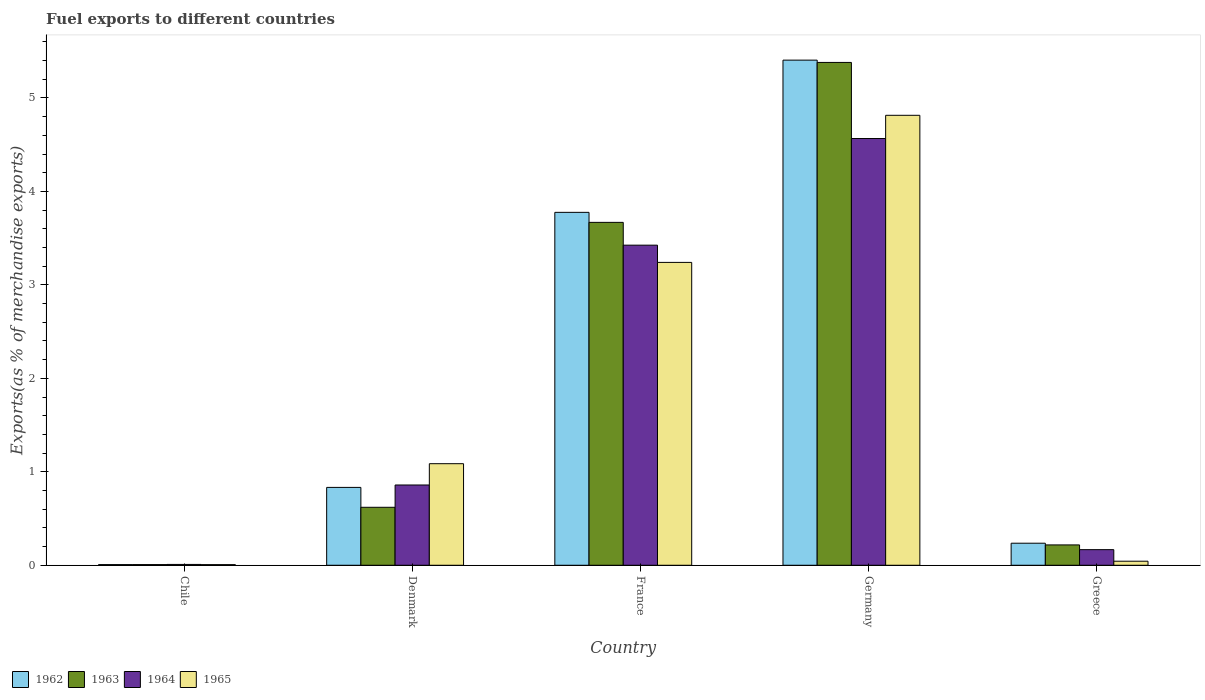Are the number of bars per tick equal to the number of legend labels?
Make the answer very short. Yes. Are the number of bars on each tick of the X-axis equal?
Provide a succinct answer. Yes. How many bars are there on the 3rd tick from the left?
Your answer should be compact. 4. How many bars are there on the 2nd tick from the right?
Your response must be concise. 4. What is the label of the 2nd group of bars from the left?
Your answer should be very brief. Denmark. In how many cases, is the number of bars for a given country not equal to the number of legend labels?
Your answer should be compact. 0. What is the percentage of exports to different countries in 1963 in Greece?
Provide a short and direct response. 0.22. Across all countries, what is the maximum percentage of exports to different countries in 1965?
Your response must be concise. 4.81. Across all countries, what is the minimum percentage of exports to different countries in 1964?
Make the answer very short. 0.01. In which country was the percentage of exports to different countries in 1963 maximum?
Ensure brevity in your answer.  Germany. In which country was the percentage of exports to different countries in 1963 minimum?
Keep it short and to the point. Chile. What is the total percentage of exports to different countries in 1965 in the graph?
Your response must be concise. 9.19. What is the difference between the percentage of exports to different countries in 1964 in Chile and that in Germany?
Keep it short and to the point. -4.56. What is the difference between the percentage of exports to different countries in 1964 in Chile and the percentage of exports to different countries in 1962 in Germany?
Offer a very short reply. -5.4. What is the average percentage of exports to different countries in 1963 per country?
Keep it short and to the point. 1.98. What is the difference between the percentage of exports to different countries of/in 1965 and percentage of exports to different countries of/in 1964 in Greece?
Provide a short and direct response. -0.12. In how many countries, is the percentage of exports to different countries in 1963 greater than 4.2 %?
Your answer should be very brief. 1. What is the ratio of the percentage of exports to different countries in 1963 in Chile to that in Denmark?
Offer a very short reply. 0.01. What is the difference between the highest and the second highest percentage of exports to different countries in 1964?
Offer a terse response. -2.57. What is the difference between the highest and the lowest percentage of exports to different countries in 1965?
Your response must be concise. 4.81. Is it the case that in every country, the sum of the percentage of exports to different countries in 1963 and percentage of exports to different countries in 1965 is greater than the sum of percentage of exports to different countries in 1962 and percentage of exports to different countries in 1964?
Offer a very short reply. No. What does the 1st bar from the left in Germany represents?
Provide a succinct answer. 1962. What does the 4th bar from the right in Chile represents?
Your response must be concise. 1962. How many bars are there?
Offer a very short reply. 20. What is the difference between two consecutive major ticks on the Y-axis?
Ensure brevity in your answer.  1. Does the graph contain grids?
Ensure brevity in your answer.  No. Where does the legend appear in the graph?
Keep it short and to the point. Bottom left. How are the legend labels stacked?
Give a very brief answer. Horizontal. What is the title of the graph?
Provide a short and direct response. Fuel exports to different countries. What is the label or title of the Y-axis?
Provide a succinct answer. Exports(as % of merchandise exports). What is the Exports(as % of merchandise exports) of 1962 in Chile?
Provide a short and direct response. 0.01. What is the Exports(as % of merchandise exports) of 1963 in Chile?
Your answer should be very brief. 0.01. What is the Exports(as % of merchandise exports) of 1964 in Chile?
Keep it short and to the point. 0.01. What is the Exports(as % of merchandise exports) of 1965 in Chile?
Your response must be concise. 0.01. What is the Exports(as % of merchandise exports) of 1962 in Denmark?
Make the answer very short. 0.83. What is the Exports(as % of merchandise exports) in 1963 in Denmark?
Provide a short and direct response. 0.62. What is the Exports(as % of merchandise exports) in 1964 in Denmark?
Your answer should be compact. 0.86. What is the Exports(as % of merchandise exports) of 1965 in Denmark?
Ensure brevity in your answer.  1.09. What is the Exports(as % of merchandise exports) in 1962 in France?
Give a very brief answer. 3.78. What is the Exports(as % of merchandise exports) of 1963 in France?
Give a very brief answer. 3.67. What is the Exports(as % of merchandise exports) in 1964 in France?
Your answer should be compact. 3.43. What is the Exports(as % of merchandise exports) of 1965 in France?
Provide a short and direct response. 3.24. What is the Exports(as % of merchandise exports) in 1962 in Germany?
Give a very brief answer. 5.4. What is the Exports(as % of merchandise exports) of 1963 in Germany?
Provide a succinct answer. 5.38. What is the Exports(as % of merchandise exports) in 1964 in Germany?
Your answer should be compact. 4.57. What is the Exports(as % of merchandise exports) of 1965 in Germany?
Give a very brief answer. 4.81. What is the Exports(as % of merchandise exports) of 1962 in Greece?
Offer a very short reply. 0.24. What is the Exports(as % of merchandise exports) of 1963 in Greece?
Provide a short and direct response. 0.22. What is the Exports(as % of merchandise exports) in 1964 in Greece?
Provide a short and direct response. 0.17. What is the Exports(as % of merchandise exports) in 1965 in Greece?
Your response must be concise. 0.04. Across all countries, what is the maximum Exports(as % of merchandise exports) in 1962?
Offer a very short reply. 5.4. Across all countries, what is the maximum Exports(as % of merchandise exports) in 1963?
Give a very brief answer. 5.38. Across all countries, what is the maximum Exports(as % of merchandise exports) of 1964?
Offer a very short reply. 4.57. Across all countries, what is the maximum Exports(as % of merchandise exports) in 1965?
Provide a short and direct response. 4.81. Across all countries, what is the minimum Exports(as % of merchandise exports) in 1962?
Make the answer very short. 0.01. Across all countries, what is the minimum Exports(as % of merchandise exports) in 1963?
Offer a terse response. 0.01. Across all countries, what is the minimum Exports(as % of merchandise exports) of 1964?
Make the answer very short. 0.01. Across all countries, what is the minimum Exports(as % of merchandise exports) of 1965?
Ensure brevity in your answer.  0.01. What is the total Exports(as % of merchandise exports) in 1962 in the graph?
Provide a short and direct response. 10.26. What is the total Exports(as % of merchandise exports) of 1963 in the graph?
Ensure brevity in your answer.  9.89. What is the total Exports(as % of merchandise exports) in 1964 in the graph?
Keep it short and to the point. 9.03. What is the total Exports(as % of merchandise exports) in 1965 in the graph?
Offer a terse response. 9.19. What is the difference between the Exports(as % of merchandise exports) of 1962 in Chile and that in Denmark?
Offer a terse response. -0.83. What is the difference between the Exports(as % of merchandise exports) of 1963 in Chile and that in Denmark?
Ensure brevity in your answer.  -0.61. What is the difference between the Exports(as % of merchandise exports) of 1964 in Chile and that in Denmark?
Give a very brief answer. -0.85. What is the difference between the Exports(as % of merchandise exports) of 1965 in Chile and that in Denmark?
Offer a terse response. -1.08. What is the difference between the Exports(as % of merchandise exports) of 1962 in Chile and that in France?
Provide a short and direct response. -3.77. What is the difference between the Exports(as % of merchandise exports) of 1963 in Chile and that in France?
Provide a succinct answer. -3.66. What is the difference between the Exports(as % of merchandise exports) of 1964 in Chile and that in France?
Give a very brief answer. -3.42. What is the difference between the Exports(as % of merchandise exports) of 1965 in Chile and that in France?
Give a very brief answer. -3.23. What is the difference between the Exports(as % of merchandise exports) in 1962 in Chile and that in Germany?
Provide a succinct answer. -5.4. What is the difference between the Exports(as % of merchandise exports) of 1963 in Chile and that in Germany?
Ensure brevity in your answer.  -5.37. What is the difference between the Exports(as % of merchandise exports) of 1964 in Chile and that in Germany?
Provide a succinct answer. -4.56. What is the difference between the Exports(as % of merchandise exports) of 1965 in Chile and that in Germany?
Provide a short and direct response. -4.81. What is the difference between the Exports(as % of merchandise exports) in 1962 in Chile and that in Greece?
Keep it short and to the point. -0.23. What is the difference between the Exports(as % of merchandise exports) of 1963 in Chile and that in Greece?
Provide a short and direct response. -0.21. What is the difference between the Exports(as % of merchandise exports) of 1964 in Chile and that in Greece?
Your response must be concise. -0.16. What is the difference between the Exports(as % of merchandise exports) of 1965 in Chile and that in Greece?
Give a very brief answer. -0.04. What is the difference between the Exports(as % of merchandise exports) in 1962 in Denmark and that in France?
Your answer should be very brief. -2.94. What is the difference between the Exports(as % of merchandise exports) in 1963 in Denmark and that in France?
Your response must be concise. -3.05. What is the difference between the Exports(as % of merchandise exports) of 1964 in Denmark and that in France?
Offer a very short reply. -2.57. What is the difference between the Exports(as % of merchandise exports) in 1965 in Denmark and that in France?
Provide a succinct answer. -2.15. What is the difference between the Exports(as % of merchandise exports) in 1962 in Denmark and that in Germany?
Offer a terse response. -4.57. What is the difference between the Exports(as % of merchandise exports) in 1963 in Denmark and that in Germany?
Your answer should be compact. -4.76. What is the difference between the Exports(as % of merchandise exports) of 1964 in Denmark and that in Germany?
Make the answer very short. -3.71. What is the difference between the Exports(as % of merchandise exports) in 1965 in Denmark and that in Germany?
Offer a terse response. -3.73. What is the difference between the Exports(as % of merchandise exports) in 1962 in Denmark and that in Greece?
Your response must be concise. 0.6. What is the difference between the Exports(as % of merchandise exports) of 1963 in Denmark and that in Greece?
Provide a succinct answer. 0.4. What is the difference between the Exports(as % of merchandise exports) in 1964 in Denmark and that in Greece?
Offer a very short reply. 0.69. What is the difference between the Exports(as % of merchandise exports) in 1965 in Denmark and that in Greece?
Make the answer very short. 1.04. What is the difference between the Exports(as % of merchandise exports) of 1962 in France and that in Germany?
Offer a terse response. -1.63. What is the difference between the Exports(as % of merchandise exports) of 1963 in France and that in Germany?
Keep it short and to the point. -1.71. What is the difference between the Exports(as % of merchandise exports) of 1964 in France and that in Germany?
Keep it short and to the point. -1.14. What is the difference between the Exports(as % of merchandise exports) in 1965 in France and that in Germany?
Your answer should be very brief. -1.57. What is the difference between the Exports(as % of merchandise exports) in 1962 in France and that in Greece?
Keep it short and to the point. 3.54. What is the difference between the Exports(as % of merchandise exports) in 1963 in France and that in Greece?
Offer a very short reply. 3.45. What is the difference between the Exports(as % of merchandise exports) in 1964 in France and that in Greece?
Make the answer very short. 3.26. What is the difference between the Exports(as % of merchandise exports) in 1965 in France and that in Greece?
Offer a very short reply. 3.2. What is the difference between the Exports(as % of merchandise exports) of 1962 in Germany and that in Greece?
Ensure brevity in your answer.  5.17. What is the difference between the Exports(as % of merchandise exports) of 1963 in Germany and that in Greece?
Your answer should be very brief. 5.16. What is the difference between the Exports(as % of merchandise exports) in 1964 in Germany and that in Greece?
Provide a short and direct response. 4.4. What is the difference between the Exports(as % of merchandise exports) in 1965 in Germany and that in Greece?
Ensure brevity in your answer.  4.77. What is the difference between the Exports(as % of merchandise exports) in 1962 in Chile and the Exports(as % of merchandise exports) in 1963 in Denmark?
Your answer should be compact. -0.61. What is the difference between the Exports(as % of merchandise exports) of 1962 in Chile and the Exports(as % of merchandise exports) of 1964 in Denmark?
Give a very brief answer. -0.85. What is the difference between the Exports(as % of merchandise exports) in 1962 in Chile and the Exports(as % of merchandise exports) in 1965 in Denmark?
Offer a terse response. -1.08. What is the difference between the Exports(as % of merchandise exports) of 1963 in Chile and the Exports(as % of merchandise exports) of 1964 in Denmark?
Your response must be concise. -0.85. What is the difference between the Exports(as % of merchandise exports) of 1963 in Chile and the Exports(as % of merchandise exports) of 1965 in Denmark?
Keep it short and to the point. -1.08. What is the difference between the Exports(as % of merchandise exports) in 1964 in Chile and the Exports(as % of merchandise exports) in 1965 in Denmark?
Make the answer very short. -1.08. What is the difference between the Exports(as % of merchandise exports) in 1962 in Chile and the Exports(as % of merchandise exports) in 1963 in France?
Your response must be concise. -3.66. What is the difference between the Exports(as % of merchandise exports) of 1962 in Chile and the Exports(as % of merchandise exports) of 1964 in France?
Offer a terse response. -3.42. What is the difference between the Exports(as % of merchandise exports) of 1962 in Chile and the Exports(as % of merchandise exports) of 1965 in France?
Provide a short and direct response. -3.23. What is the difference between the Exports(as % of merchandise exports) of 1963 in Chile and the Exports(as % of merchandise exports) of 1964 in France?
Ensure brevity in your answer.  -3.42. What is the difference between the Exports(as % of merchandise exports) of 1963 in Chile and the Exports(as % of merchandise exports) of 1965 in France?
Your answer should be compact. -3.23. What is the difference between the Exports(as % of merchandise exports) of 1964 in Chile and the Exports(as % of merchandise exports) of 1965 in France?
Offer a very short reply. -3.23. What is the difference between the Exports(as % of merchandise exports) of 1962 in Chile and the Exports(as % of merchandise exports) of 1963 in Germany?
Make the answer very short. -5.37. What is the difference between the Exports(as % of merchandise exports) of 1962 in Chile and the Exports(as % of merchandise exports) of 1964 in Germany?
Ensure brevity in your answer.  -4.56. What is the difference between the Exports(as % of merchandise exports) in 1962 in Chile and the Exports(as % of merchandise exports) in 1965 in Germany?
Offer a terse response. -4.81. What is the difference between the Exports(as % of merchandise exports) in 1963 in Chile and the Exports(as % of merchandise exports) in 1964 in Germany?
Provide a short and direct response. -4.56. What is the difference between the Exports(as % of merchandise exports) of 1963 in Chile and the Exports(as % of merchandise exports) of 1965 in Germany?
Offer a very short reply. -4.81. What is the difference between the Exports(as % of merchandise exports) in 1964 in Chile and the Exports(as % of merchandise exports) in 1965 in Germany?
Offer a terse response. -4.81. What is the difference between the Exports(as % of merchandise exports) of 1962 in Chile and the Exports(as % of merchandise exports) of 1963 in Greece?
Your response must be concise. -0.21. What is the difference between the Exports(as % of merchandise exports) in 1962 in Chile and the Exports(as % of merchandise exports) in 1964 in Greece?
Your answer should be compact. -0.16. What is the difference between the Exports(as % of merchandise exports) in 1962 in Chile and the Exports(as % of merchandise exports) in 1965 in Greece?
Keep it short and to the point. -0.04. What is the difference between the Exports(as % of merchandise exports) of 1963 in Chile and the Exports(as % of merchandise exports) of 1964 in Greece?
Make the answer very short. -0.16. What is the difference between the Exports(as % of merchandise exports) in 1963 in Chile and the Exports(as % of merchandise exports) in 1965 in Greece?
Provide a succinct answer. -0.04. What is the difference between the Exports(as % of merchandise exports) in 1964 in Chile and the Exports(as % of merchandise exports) in 1965 in Greece?
Your response must be concise. -0.03. What is the difference between the Exports(as % of merchandise exports) in 1962 in Denmark and the Exports(as % of merchandise exports) in 1963 in France?
Provide a short and direct response. -2.84. What is the difference between the Exports(as % of merchandise exports) of 1962 in Denmark and the Exports(as % of merchandise exports) of 1964 in France?
Offer a terse response. -2.59. What is the difference between the Exports(as % of merchandise exports) of 1962 in Denmark and the Exports(as % of merchandise exports) of 1965 in France?
Provide a short and direct response. -2.41. What is the difference between the Exports(as % of merchandise exports) of 1963 in Denmark and the Exports(as % of merchandise exports) of 1964 in France?
Make the answer very short. -2.8. What is the difference between the Exports(as % of merchandise exports) of 1963 in Denmark and the Exports(as % of merchandise exports) of 1965 in France?
Your response must be concise. -2.62. What is the difference between the Exports(as % of merchandise exports) in 1964 in Denmark and the Exports(as % of merchandise exports) in 1965 in France?
Offer a very short reply. -2.38. What is the difference between the Exports(as % of merchandise exports) in 1962 in Denmark and the Exports(as % of merchandise exports) in 1963 in Germany?
Offer a very short reply. -4.55. What is the difference between the Exports(as % of merchandise exports) of 1962 in Denmark and the Exports(as % of merchandise exports) of 1964 in Germany?
Your answer should be very brief. -3.73. What is the difference between the Exports(as % of merchandise exports) in 1962 in Denmark and the Exports(as % of merchandise exports) in 1965 in Germany?
Provide a succinct answer. -3.98. What is the difference between the Exports(as % of merchandise exports) in 1963 in Denmark and the Exports(as % of merchandise exports) in 1964 in Germany?
Your answer should be very brief. -3.95. What is the difference between the Exports(as % of merchandise exports) of 1963 in Denmark and the Exports(as % of merchandise exports) of 1965 in Germany?
Give a very brief answer. -4.19. What is the difference between the Exports(as % of merchandise exports) of 1964 in Denmark and the Exports(as % of merchandise exports) of 1965 in Germany?
Provide a short and direct response. -3.96. What is the difference between the Exports(as % of merchandise exports) in 1962 in Denmark and the Exports(as % of merchandise exports) in 1963 in Greece?
Provide a short and direct response. 0.62. What is the difference between the Exports(as % of merchandise exports) of 1962 in Denmark and the Exports(as % of merchandise exports) of 1964 in Greece?
Keep it short and to the point. 0.67. What is the difference between the Exports(as % of merchandise exports) of 1962 in Denmark and the Exports(as % of merchandise exports) of 1965 in Greece?
Give a very brief answer. 0.79. What is the difference between the Exports(as % of merchandise exports) in 1963 in Denmark and the Exports(as % of merchandise exports) in 1964 in Greece?
Provide a short and direct response. 0.45. What is the difference between the Exports(as % of merchandise exports) of 1963 in Denmark and the Exports(as % of merchandise exports) of 1965 in Greece?
Provide a short and direct response. 0.58. What is the difference between the Exports(as % of merchandise exports) in 1964 in Denmark and the Exports(as % of merchandise exports) in 1965 in Greece?
Make the answer very short. 0.82. What is the difference between the Exports(as % of merchandise exports) in 1962 in France and the Exports(as % of merchandise exports) in 1963 in Germany?
Make the answer very short. -1.6. What is the difference between the Exports(as % of merchandise exports) of 1962 in France and the Exports(as % of merchandise exports) of 1964 in Germany?
Offer a terse response. -0.79. What is the difference between the Exports(as % of merchandise exports) of 1962 in France and the Exports(as % of merchandise exports) of 1965 in Germany?
Provide a succinct answer. -1.04. What is the difference between the Exports(as % of merchandise exports) in 1963 in France and the Exports(as % of merchandise exports) in 1964 in Germany?
Your response must be concise. -0.9. What is the difference between the Exports(as % of merchandise exports) of 1963 in France and the Exports(as % of merchandise exports) of 1965 in Germany?
Provide a succinct answer. -1.15. What is the difference between the Exports(as % of merchandise exports) in 1964 in France and the Exports(as % of merchandise exports) in 1965 in Germany?
Offer a very short reply. -1.39. What is the difference between the Exports(as % of merchandise exports) in 1962 in France and the Exports(as % of merchandise exports) in 1963 in Greece?
Offer a terse response. 3.56. What is the difference between the Exports(as % of merchandise exports) in 1962 in France and the Exports(as % of merchandise exports) in 1964 in Greece?
Your response must be concise. 3.61. What is the difference between the Exports(as % of merchandise exports) in 1962 in France and the Exports(as % of merchandise exports) in 1965 in Greece?
Your answer should be compact. 3.73. What is the difference between the Exports(as % of merchandise exports) in 1963 in France and the Exports(as % of merchandise exports) in 1964 in Greece?
Make the answer very short. 3.5. What is the difference between the Exports(as % of merchandise exports) in 1963 in France and the Exports(as % of merchandise exports) in 1965 in Greece?
Your response must be concise. 3.63. What is the difference between the Exports(as % of merchandise exports) of 1964 in France and the Exports(as % of merchandise exports) of 1965 in Greece?
Your answer should be compact. 3.38. What is the difference between the Exports(as % of merchandise exports) in 1962 in Germany and the Exports(as % of merchandise exports) in 1963 in Greece?
Provide a short and direct response. 5.19. What is the difference between the Exports(as % of merchandise exports) in 1962 in Germany and the Exports(as % of merchandise exports) in 1964 in Greece?
Your answer should be very brief. 5.24. What is the difference between the Exports(as % of merchandise exports) in 1962 in Germany and the Exports(as % of merchandise exports) in 1965 in Greece?
Provide a short and direct response. 5.36. What is the difference between the Exports(as % of merchandise exports) in 1963 in Germany and the Exports(as % of merchandise exports) in 1964 in Greece?
Offer a terse response. 5.21. What is the difference between the Exports(as % of merchandise exports) in 1963 in Germany and the Exports(as % of merchandise exports) in 1965 in Greece?
Offer a terse response. 5.34. What is the difference between the Exports(as % of merchandise exports) of 1964 in Germany and the Exports(as % of merchandise exports) of 1965 in Greece?
Provide a succinct answer. 4.52. What is the average Exports(as % of merchandise exports) of 1962 per country?
Make the answer very short. 2.05. What is the average Exports(as % of merchandise exports) of 1963 per country?
Your answer should be compact. 1.98. What is the average Exports(as % of merchandise exports) of 1964 per country?
Your response must be concise. 1.81. What is the average Exports(as % of merchandise exports) of 1965 per country?
Your answer should be very brief. 1.84. What is the difference between the Exports(as % of merchandise exports) of 1962 and Exports(as % of merchandise exports) of 1963 in Chile?
Provide a succinct answer. -0. What is the difference between the Exports(as % of merchandise exports) of 1962 and Exports(as % of merchandise exports) of 1964 in Chile?
Keep it short and to the point. -0. What is the difference between the Exports(as % of merchandise exports) in 1962 and Exports(as % of merchandise exports) in 1965 in Chile?
Your response must be concise. 0. What is the difference between the Exports(as % of merchandise exports) of 1963 and Exports(as % of merchandise exports) of 1964 in Chile?
Give a very brief answer. -0. What is the difference between the Exports(as % of merchandise exports) of 1964 and Exports(as % of merchandise exports) of 1965 in Chile?
Your answer should be compact. 0. What is the difference between the Exports(as % of merchandise exports) in 1962 and Exports(as % of merchandise exports) in 1963 in Denmark?
Give a very brief answer. 0.21. What is the difference between the Exports(as % of merchandise exports) in 1962 and Exports(as % of merchandise exports) in 1964 in Denmark?
Your answer should be compact. -0.03. What is the difference between the Exports(as % of merchandise exports) in 1962 and Exports(as % of merchandise exports) in 1965 in Denmark?
Provide a succinct answer. -0.25. What is the difference between the Exports(as % of merchandise exports) in 1963 and Exports(as % of merchandise exports) in 1964 in Denmark?
Offer a very short reply. -0.24. What is the difference between the Exports(as % of merchandise exports) in 1963 and Exports(as % of merchandise exports) in 1965 in Denmark?
Your answer should be compact. -0.47. What is the difference between the Exports(as % of merchandise exports) in 1964 and Exports(as % of merchandise exports) in 1965 in Denmark?
Provide a short and direct response. -0.23. What is the difference between the Exports(as % of merchandise exports) of 1962 and Exports(as % of merchandise exports) of 1963 in France?
Your answer should be very brief. 0.11. What is the difference between the Exports(as % of merchandise exports) of 1962 and Exports(as % of merchandise exports) of 1964 in France?
Provide a succinct answer. 0.35. What is the difference between the Exports(as % of merchandise exports) in 1962 and Exports(as % of merchandise exports) in 1965 in France?
Your response must be concise. 0.54. What is the difference between the Exports(as % of merchandise exports) in 1963 and Exports(as % of merchandise exports) in 1964 in France?
Ensure brevity in your answer.  0.24. What is the difference between the Exports(as % of merchandise exports) in 1963 and Exports(as % of merchandise exports) in 1965 in France?
Make the answer very short. 0.43. What is the difference between the Exports(as % of merchandise exports) of 1964 and Exports(as % of merchandise exports) of 1965 in France?
Your answer should be very brief. 0.18. What is the difference between the Exports(as % of merchandise exports) in 1962 and Exports(as % of merchandise exports) in 1963 in Germany?
Your answer should be very brief. 0.02. What is the difference between the Exports(as % of merchandise exports) in 1962 and Exports(as % of merchandise exports) in 1964 in Germany?
Keep it short and to the point. 0.84. What is the difference between the Exports(as % of merchandise exports) in 1962 and Exports(as % of merchandise exports) in 1965 in Germany?
Provide a short and direct response. 0.59. What is the difference between the Exports(as % of merchandise exports) in 1963 and Exports(as % of merchandise exports) in 1964 in Germany?
Offer a very short reply. 0.81. What is the difference between the Exports(as % of merchandise exports) in 1963 and Exports(as % of merchandise exports) in 1965 in Germany?
Make the answer very short. 0.57. What is the difference between the Exports(as % of merchandise exports) of 1964 and Exports(as % of merchandise exports) of 1965 in Germany?
Make the answer very short. -0.25. What is the difference between the Exports(as % of merchandise exports) of 1962 and Exports(as % of merchandise exports) of 1963 in Greece?
Offer a terse response. 0.02. What is the difference between the Exports(as % of merchandise exports) of 1962 and Exports(as % of merchandise exports) of 1964 in Greece?
Provide a succinct answer. 0.07. What is the difference between the Exports(as % of merchandise exports) of 1962 and Exports(as % of merchandise exports) of 1965 in Greece?
Give a very brief answer. 0.19. What is the difference between the Exports(as % of merchandise exports) in 1963 and Exports(as % of merchandise exports) in 1964 in Greece?
Provide a succinct answer. 0.05. What is the difference between the Exports(as % of merchandise exports) in 1963 and Exports(as % of merchandise exports) in 1965 in Greece?
Offer a very short reply. 0.17. What is the difference between the Exports(as % of merchandise exports) in 1964 and Exports(as % of merchandise exports) in 1965 in Greece?
Provide a succinct answer. 0.12. What is the ratio of the Exports(as % of merchandise exports) of 1962 in Chile to that in Denmark?
Ensure brevity in your answer.  0.01. What is the ratio of the Exports(as % of merchandise exports) of 1963 in Chile to that in Denmark?
Make the answer very short. 0.01. What is the ratio of the Exports(as % of merchandise exports) in 1964 in Chile to that in Denmark?
Your response must be concise. 0.01. What is the ratio of the Exports(as % of merchandise exports) in 1965 in Chile to that in Denmark?
Offer a terse response. 0.01. What is the ratio of the Exports(as % of merchandise exports) in 1962 in Chile to that in France?
Ensure brevity in your answer.  0. What is the ratio of the Exports(as % of merchandise exports) in 1963 in Chile to that in France?
Ensure brevity in your answer.  0. What is the ratio of the Exports(as % of merchandise exports) of 1964 in Chile to that in France?
Ensure brevity in your answer.  0. What is the ratio of the Exports(as % of merchandise exports) of 1965 in Chile to that in France?
Provide a short and direct response. 0. What is the ratio of the Exports(as % of merchandise exports) in 1962 in Chile to that in Germany?
Ensure brevity in your answer.  0. What is the ratio of the Exports(as % of merchandise exports) of 1963 in Chile to that in Germany?
Your response must be concise. 0. What is the ratio of the Exports(as % of merchandise exports) in 1964 in Chile to that in Germany?
Offer a terse response. 0. What is the ratio of the Exports(as % of merchandise exports) in 1965 in Chile to that in Germany?
Provide a short and direct response. 0. What is the ratio of the Exports(as % of merchandise exports) of 1962 in Chile to that in Greece?
Your response must be concise. 0.03. What is the ratio of the Exports(as % of merchandise exports) in 1963 in Chile to that in Greece?
Offer a very short reply. 0.03. What is the ratio of the Exports(as % of merchandise exports) in 1964 in Chile to that in Greece?
Provide a succinct answer. 0.05. What is the ratio of the Exports(as % of merchandise exports) in 1965 in Chile to that in Greece?
Your answer should be very brief. 0.16. What is the ratio of the Exports(as % of merchandise exports) in 1962 in Denmark to that in France?
Your response must be concise. 0.22. What is the ratio of the Exports(as % of merchandise exports) of 1963 in Denmark to that in France?
Provide a succinct answer. 0.17. What is the ratio of the Exports(as % of merchandise exports) in 1964 in Denmark to that in France?
Keep it short and to the point. 0.25. What is the ratio of the Exports(as % of merchandise exports) in 1965 in Denmark to that in France?
Ensure brevity in your answer.  0.34. What is the ratio of the Exports(as % of merchandise exports) of 1962 in Denmark to that in Germany?
Provide a succinct answer. 0.15. What is the ratio of the Exports(as % of merchandise exports) of 1963 in Denmark to that in Germany?
Offer a very short reply. 0.12. What is the ratio of the Exports(as % of merchandise exports) in 1964 in Denmark to that in Germany?
Offer a terse response. 0.19. What is the ratio of the Exports(as % of merchandise exports) in 1965 in Denmark to that in Germany?
Ensure brevity in your answer.  0.23. What is the ratio of the Exports(as % of merchandise exports) of 1962 in Denmark to that in Greece?
Give a very brief answer. 3.53. What is the ratio of the Exports(as % of merchandise exports) in 1963 in Denmark to that in Greece?
Keep it short and to the point. 2.85. What is the ratio of the Exports(as % of merchandise exports) of 1964 in Denmark to that in Greece?
Give a very brief answer. 5.14. What is the ratio of the Exports(as % of merchandise exports) in 1965 in Denmark to that in Greece?
Your response must be concise. 25.05. What is the ratio of the Exports(as % of merchandise exports) in 1962 in France to that in Germany?
Ensure brevity in your answer.  0.7. What is the ratio of the Exports(as % of merchandise exports) of 1963 in France to that in Germany?
Keep it short and to the point. 0.68. What is the ratio of the Exports(as % of merchandise exports) of 1964 in France to that in Germany?
Offer a very short reply. 0.75. What is the ratio of the Exports(as % of merchandise exports) of 1965 in France to that in Germany?
Ensure brevity in your answer.  0.67. What is the ratio of the Exports(as % of merchandise exports) in 1962 in France to that in Greece?
Give a very brief answer. 16.01. What is the ratio of the Exports(as % of merchandise exports) in 1963 in France to that in Greece?
Provide a succinct answer. 16.85. What is the ratio of the Exports(as % of merchandise exports) of 1964 in France to that in Greece?
Offer a very short reply. 20.5. What is the ratio of the Exports(as % of merchandise exports) in 1965 in France to that in Greece?
Your answer should be compact. 74.69. What is the ratio of the Exports(as % of merchandise exports) of 1962 in Germany to that in Greece?
Make the answer very short. 22.91. What is the ratio of the Exports(as % of merchandise exports) in 1963 in Germany to that in Greece?
Your answer should be very brief. 24.71. What is the ratio of the Exports(as % of merchandise exports) of 1964 in Germany to that in Greece?
Keep it short and to the point. 27.34. What is the ratio of the Exports(as % of merchandise exports) of 1965 in Germany to that in Greece?
Make the answer very short. 110.96. What is the difference between the highest and the second highest Exports(as % of merchandise exports) of 1962?
Provide a short and direct response. 1.63. What is the difference between the highest and the second highest Exports(as % of merchandise exports) of 1963?
Give a very brief answer. 1.71. What is the difference between the highest and the second highest Exports(as % of merchandise exports) in 1964?
Keep it short and to the point. 1.14. What is the difference between the highest and the second highest Exports(as % of merchandise exports) of 1965?
Provide a short and direct response. 1.57. What is the difference between the highest and the lowest Exports(as % of merchandise exports) of 1962?
Give a very brief answer. 5.4. What is the difference between the highest and the lowest Exports(as % of merchandise exports) of 1963?
Your answer should be very brief. 5.37. What is the difference between the highest and the lowest Exports(as % of merchandise exports) in 1964?
Ensure brevity in your answer.  4.56. What is the difference between the highest and the lowest Exports(as % of merchandise exports) of 1965?
Keep it short and to the point. 4.81. 